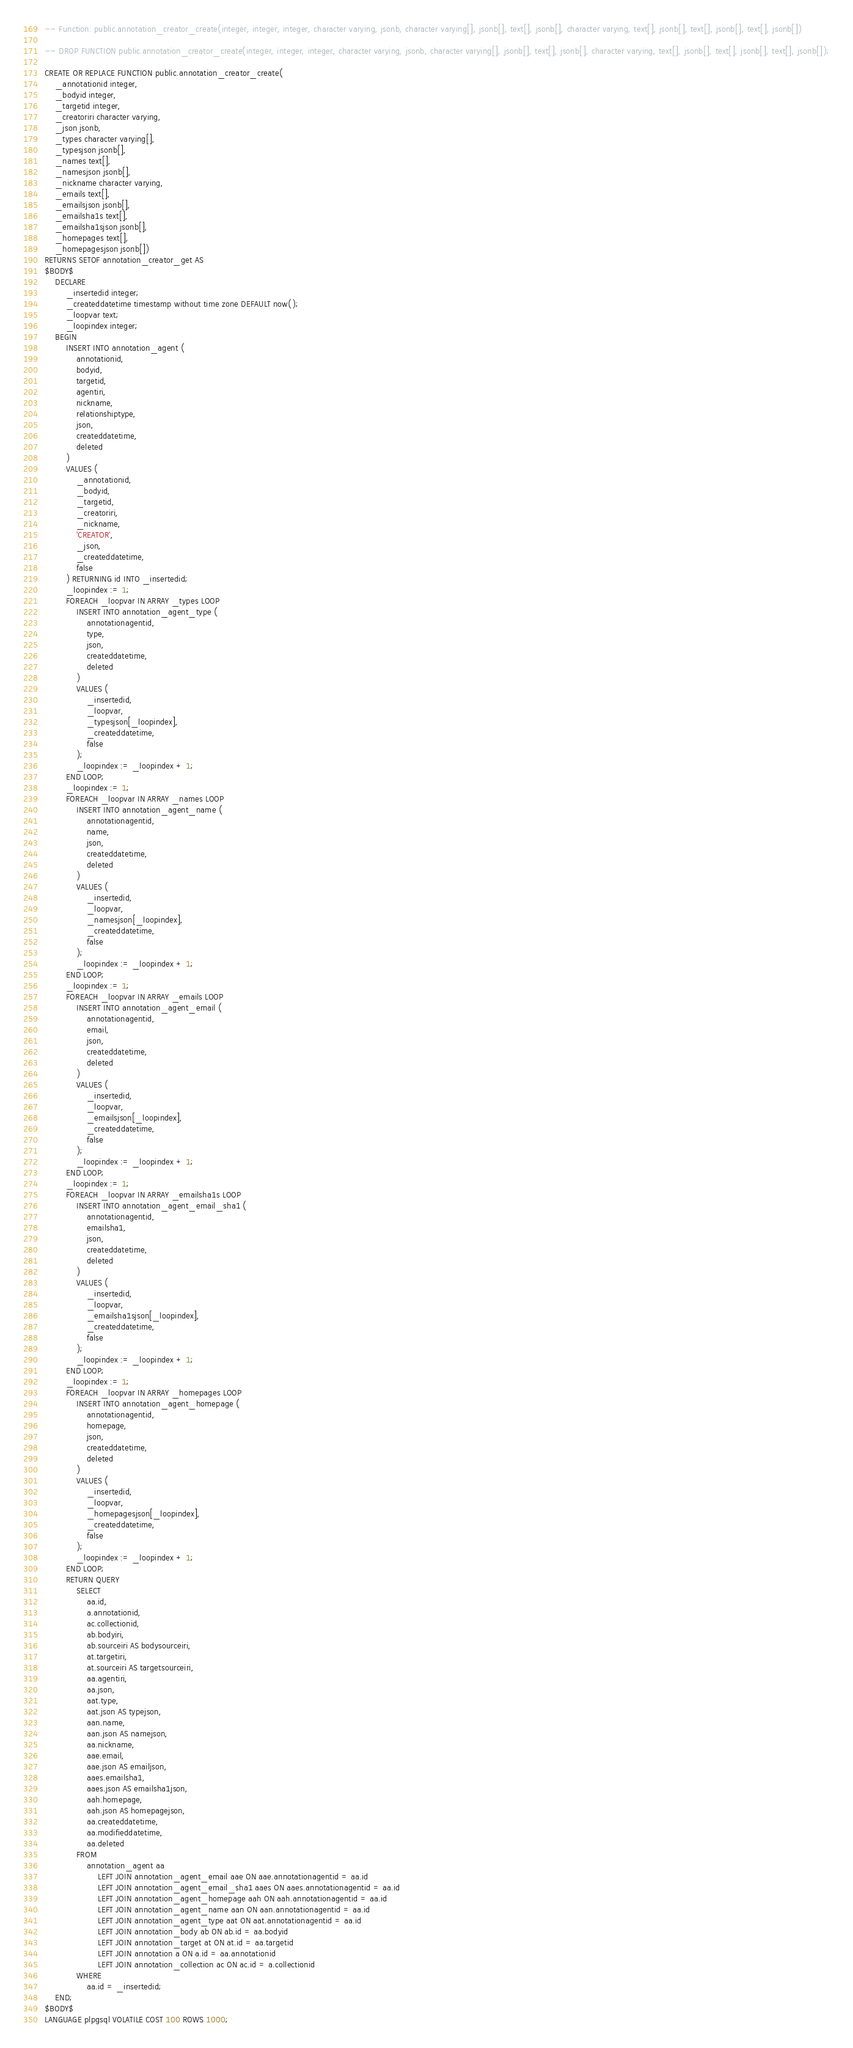<code> <loc_0><loc_0><loc_500><loc_500><_SQL_>-- Function: public.annotation_creator_create(integer, integer, integer, character varying, jsonb, character varying[], jsonb[], text[], jsonb[], character varying, text[], jsonb[], text[], jsonb[], text[], jsonb[])

-- DROP FUNCTION public.annotation_creator_create(integer, integer, integer, character varying, jsonb, character varying[], jsonb[], text[], jsonb[], character varying, text[], jsonb[], text[], jsonb[], text[], jsonb[]);

CREATE OR REPLACE FUNCTION public.annotation_creator_create(
    _annotationid integer,
    _bodyid integer,
    _targetid integer,
    _creatoriri character varying,
    _json jsonb,
    _types character varying[],
    _typesjson jsonb[],
    _names text[],
    _namesjson jsonb[],
    _nickname character varying,
    _emails text[],
    _emailsjson jsonb[],
    _emailsha1s text[],
    _emailsha1sjson jsonb[],
    _homepages text[],
    _homepagesjson jsonb[])
RETURNS SETOF annotation_creator_get AS
$BODY$
    DECLARE
        _insertedid integer;
        _createddatetime timestamp without time zone DEFAULT now();
        _loopvar text;
        _loopindex integer;
    BEGIN
        INSERT INTO annotation_agent (
            annotationid,
            bodyid,
            targetid,
            agentiri,
            nickname,
            relationshiptype,
            json,
            createddatetime,
            deleted
        )
        VALUES (
            _annotationid,
            _bodyid,
            _targetid,
            _creatoriri,
            _nickname,
            'CREATOR',
            _json,
            _createddatetime,
            false
        ) RETURNING id INTO _insertedid;
        _loopindex := 1;
        FOREACH _loopvar IN ARRAY _types LOOP
            INSERT INTO annotation_agent_type (
                annotationagentid,
                type,
                json,
                createddatetime,
                deleted
            )
            VALUES (
                _insertedid,
                _loopvar,
                _typesjson[_loopindex],
                _createddatetime,
                false
            );
            _loopindex := _loopindex + 1;
        END LOOP;
        _loopindex := 1;
        FOREACH _loopvar IN ARRAY _names LOOP
            INSERT INTO annotation_agent_name (
                annotationagentid,
                name,
                json,
                createddatetime,
                deleted
            )
            VALUES (
                _insertedid,
                _loopvar,
                _namesjson[_loopindex],
                _createddatetime,
                false
            );
            _loopindex := _loopindex + 1;
        END LOOP;
        _loopindex := 1;
        FOREACH _loopvar IN ARRAY _emails LOOP
            INSERT INTO annotation_agent_email (
                annotationagentid,
                email,
                json,
                createddatetime,
                deleted
            )
            VALUES (
                _insertedid,
                _loopvar,
                _emailsjson[_loopindex],
                _createddatetime,
                false
            );
            _loopindex := _loopindex + 1;
        END LOOP;
        _loopindex := 1;
        FOREACH _loopvar IN ARRAY _emailsha1s LOOP
            INSERT INTO annotation_agent_email_sha1 (
                annotationagentid,
                emailsha1,
                json,
                createddatetime,
                deleted
            )
            VALUES (
                _insertedid,
                _loopvar,
                _emailsha1sjson[_loopindex],
                _createddatetime,
                false
            );
            _loopindex := _loopindex + 1;
        END LOOP;
        _loopindex := 1;
        FOREACH _loopvar IN ARRAY _homepages LOOP
            INSERT INTO annotation_agent_homepage (
                annotationagentid,
                homepage,
                json,
                createddatetime,
                deleted
            )
            VALUES (
                _insertedid,
                _loopvar,
                _homepagesjson[_loopindex],
                _createddatetime,
                false
            );
            _loopindex := _loopindex + 1;
        END LOOP;
        RETURN QUERY
            SELECT
                aa.id,
                a.annotationid,
                ac.collectionid,
                ab.bodyiri,
                ab.sourceiri AS bodysourceiri,
                at.targetiri,
                at.sourceiri AS targetsourceiri,
                aa.agentiri,
                aa.json,
                aat.type,
                aat.json AS typejson,
                aan.name,
                aan.json AS namejson,
                aa.nickname,
                aae.email,
                aae.json AS emailjson,
                aaes.emailsha1,
                aaes.json AS emailsha1json,
                aah.homepage,
                aah.json AS homepagejson,
                aa.createddatetime,
                aa.modifieddatetime,
                aa.deleted
            FROM
                annotation_agent aa
                    LEFT JOIN annotation_agent_email aae ON aae.annotationagentid = aa.id
                    LEFT JOIN annotation_agent_email_sha1 aaes ON aaes.annotationagentid = aa.id
                    LEFT JOIN annotation_agent_homepage aah ON aah.annotationagentid = aa.id
                    LEFT JOIN annotation_agent_name aan ON aan.annotationagentid = aa.id
                    LEFT JOIN annotation_agent_type aat ON aat.annotationagentid = aa.id
                    LEFT JOIN annotation_body ab ON ab.id = aa.bodyid
                    LEFT JOIN annotation_target at ON at.id = aa.targetid
                    LEFT JOIN annotation a ON a.id = aa.annotationid
                    LEFT JOIN annotation_collection ac ON ac.id = a.collectionid
            WHERE
                aa.id = _insertedid;
    END;
$BODY$
LANGUAGE plpgsql VOLATILE COST 100 ROWS 1000;
</code> 